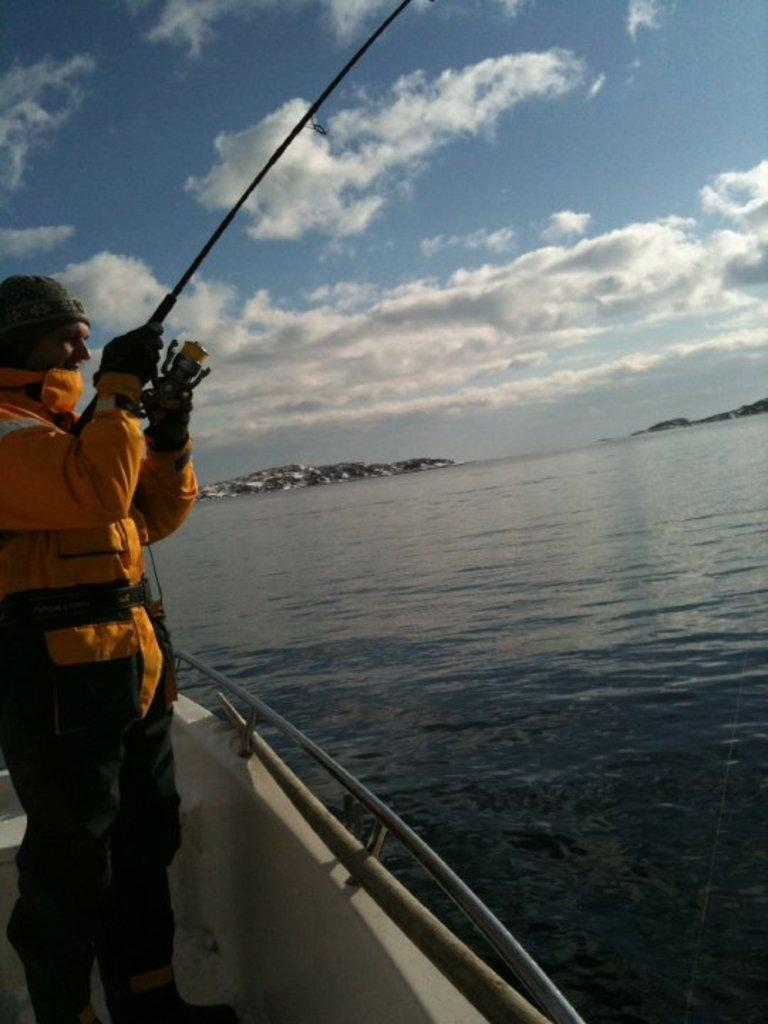Who is present in the image? There is a person in the image. What is the person doing in the image? The person is holding a fishing rod. What type of boat is the person in? The person is in a white color boat. What is the surrounding environment like in the image? There is water visible in the image, and there are mountains in the image. What is the color of the sky in the image? The sky is a combination of white and blue colors. What type of cannon is being used to prepare the meal in the image? There is no cannon or meal preparation visible in the image. What type of ray can be seen swimming in the water in the image? There are no rays visible in the water in the image. 